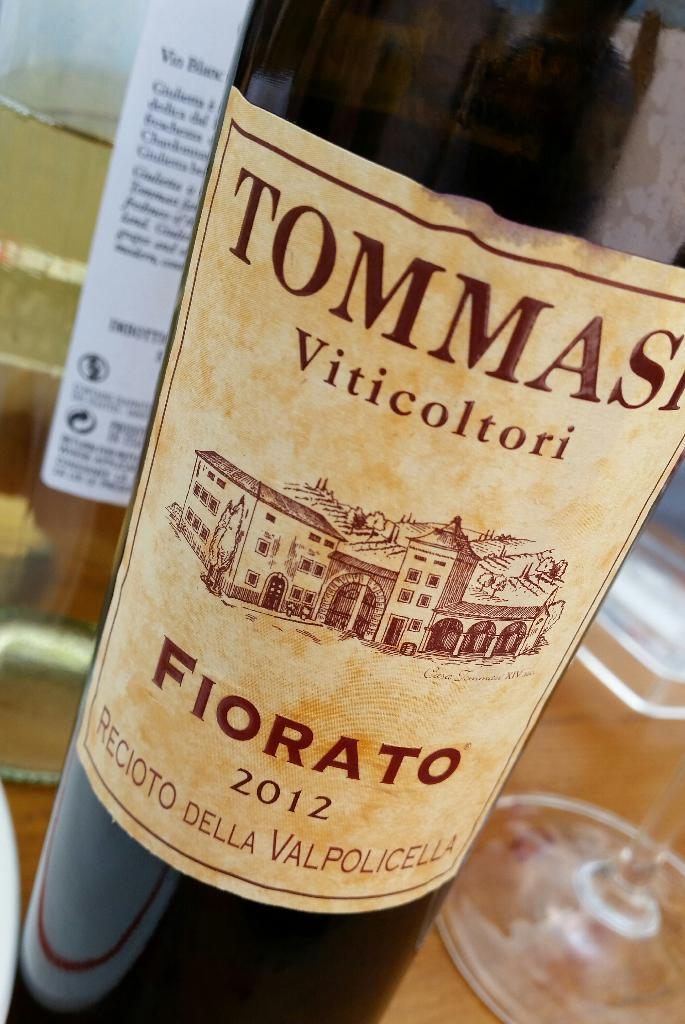What is located in the foreground of the image? There is a bottle in the foreground of the image. What else can be seen in the background of the image? There is another bottle and a glass in the background of the image. What is the surface material of the object in the background? The object in the background is on a wooden surface. What is the rate of the oven in the image? There is no oven present in the image, so it is not possible to determine the rate. 